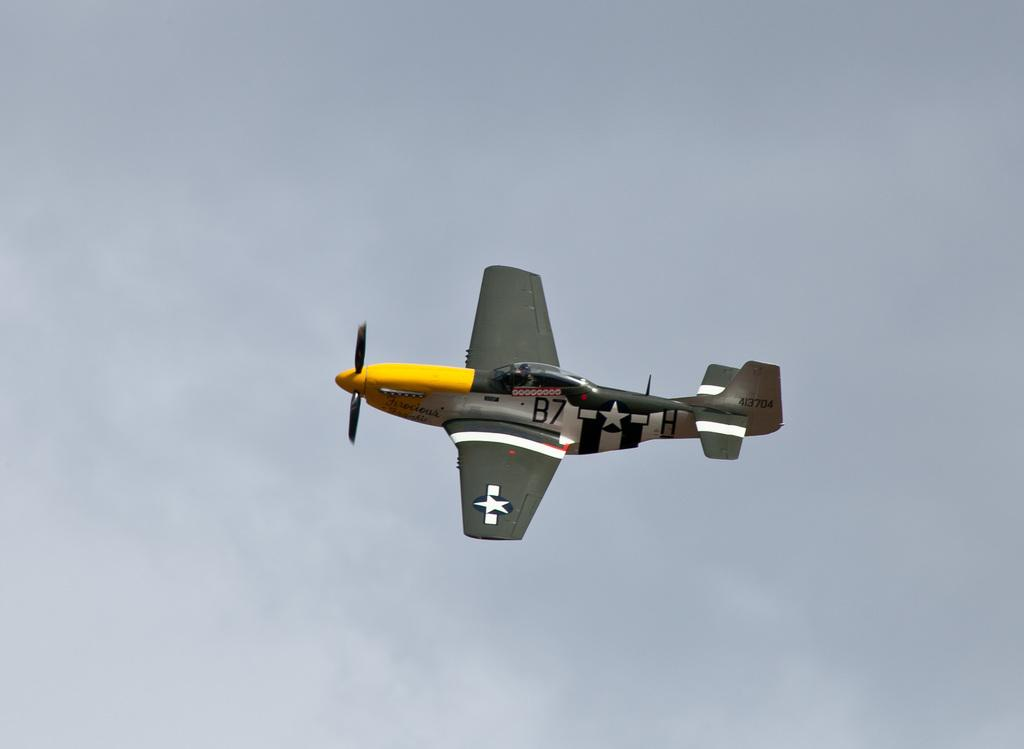<image>
Provide a brief description of the given image. A small plane labeled B7 is flying through the air. 